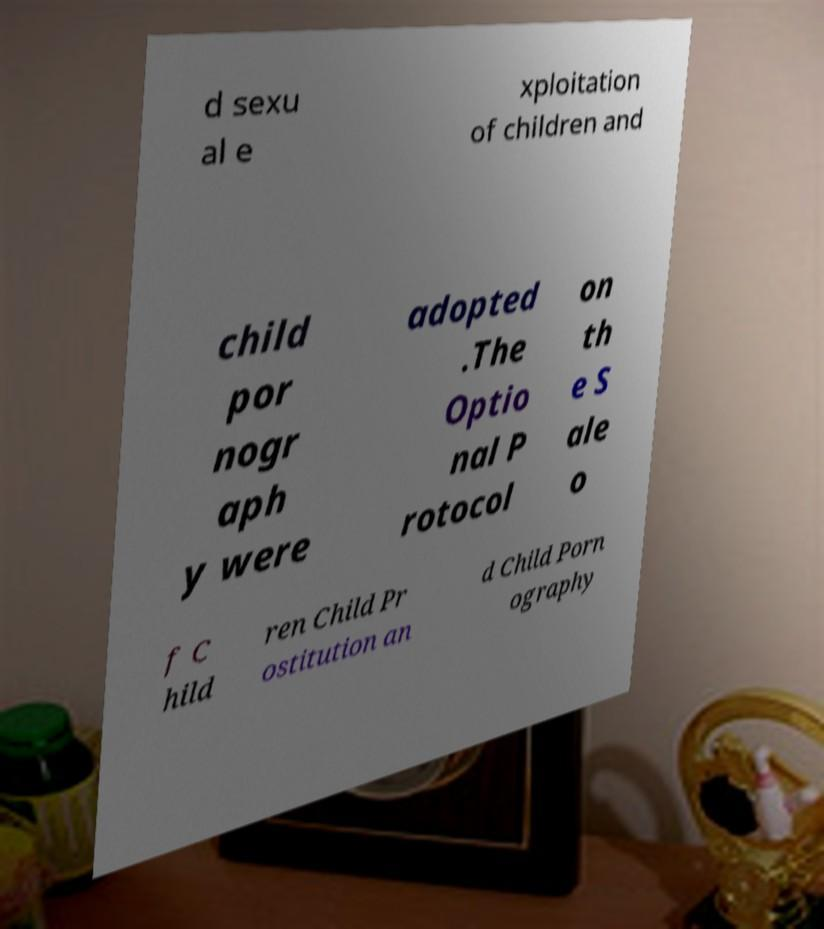Could you extract and type out the text from this image? d sexu al e xploitation of children and child por nogr aph y were adopted .The Optio nal P rotocol on th e S ale o f C hild ren Child Pr ostitution an d Child Porn ography 